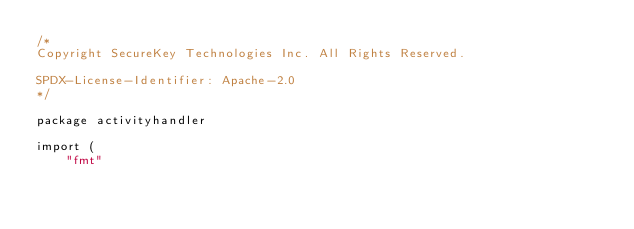<code> <loc_0><loc_0><loc_500><loc_500><_Go_>/*
Copyright SecureKey Technologies Inc. All Rights Reserved.

SPDX-License-Identifier: Apache-2.0
*/

package activityhandler

import (
	"fmt"</code> 